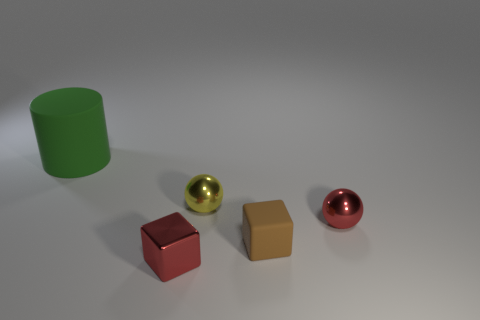There is a metallic sphere to the right of the yellow shiny sphere; is its color the same as the small metal block?
Offer a terse response. Yes. What size is the object that is both in front of the yellow metal object and on the left side of the small brown cube?
Give a very brief answer. Small. What number of tiny things are metallic spheres or shiny things?
Ensure brevity in your answer.  3. What is the shape of the metallic object that is in front of the brown block?
Your answer should be very brief. Cube. How many big brown matte blocks are there?
Make the answer very short. 0. Is the big green object made of the same material as the yellow sphere?
Your response must be concise. No. Are there more tiny metallic things that are in front of the brown rubber thing than small cyan cylinders?
Offer a terse response. Yes. What number of objects are small red blocks or things that are right of the green cylinder?
Offer a very short reply. 4. Are there more small red blocks behind the tiny metallic block than large rubber things on the left side of the matte cube?
Make the answer very short. No. What material is the tiny brown thing in front of the tiny red object that is to the right of the red shiny object in front of the tiny red sphere?
Provide a succinct answer. Rubber. 